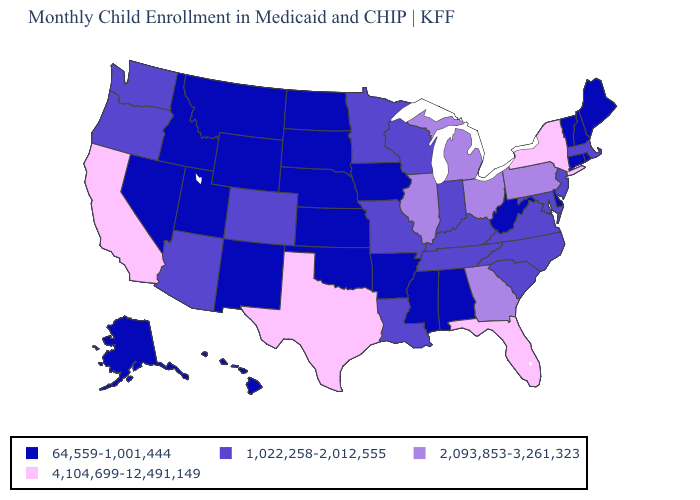What is the value of Oklahoma?
Short answer required. 64,559-1,001,444. Which states hav the highest value in the Northeast?
Answer briefly. New York. What is the value of Connecticut?
Answer briefly. 64,559-1,001,444. Name the states that have a value in the range 1,022,258-2,012,555?
Short answer required. Arizona, Colorado, Indiana, Kentucky, Louisiana, Maryland, Massachusetts, Minnesota, Missouri, New Jersey, North Carolina, Oregon, South Carolina, Tennessee, Virginia, Washington, Wisconsin. What is the value of Tennessee?
Short answer required. 1,022,258-2,012,555. Name the states that have a value in the range 64,559-1,001,444?
Concise answer only. Alabama, Alaska, Arkansas, Connecticut, Delaware, Hawaii, Idaho, Iowa, Kansas, Maine, Mississippi, Montana, Nebraska, Nevada, New Hampshire, New Mexico, North Dakota, Oklahoma, Rhode Island, South Dakota, Utah, Vermont, West Virginia, Wyoming. Does Florida have a lower value than Louisiana?
Short answer required. No. Does Rhode Island have the highest value in the Northeast?
Give a very brief answer. No. Does New York have the highest value in the Northeast?
Write a very short answer. Yes. Does West Virginia have a higher value than Hawaii?
Answer briefly. No. Name the states that have a value in the range 1,022,258-2,012,555?
Quick response, please. Arizona, Colorado, Indiana, Kentucky, Louisiana, Maryland, Massachusetts, Minnesota, Missouri, New Jersey, North Carolina, Oregon, South Carolina, Tennessee, Virginia, Washington, Wisconsin. Name the states that have a value in the range 1,022,258-2,012,555?
Write a very short answer. Arizona, Colorado, Indiana, Kentucky, Louisiana, Maryland, Massachusetts, Minnesota, Missouri, New Jersey, North Carolina, Oregon, South Carolina, Tennessee, Virginia, Washington, Wisconsin. What is the value of Vermont?
Short answer required. 64,559-1,001,444. Which states have the lowest value in the Northeast?
Quick response, please. Connecticut, Maine, New Hampshire, Rhode Island, Vermont. Does Texas have the same value as Arizona?
Answer briefly. No. 